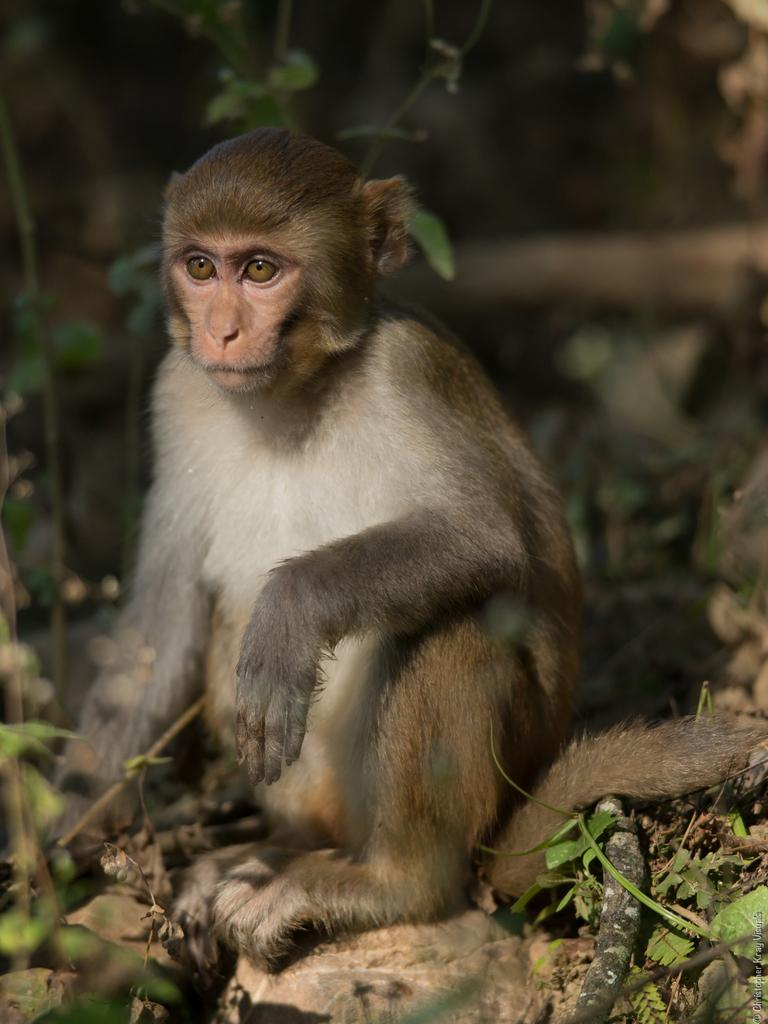What animal is present in the image? There is a monkey in the image. What is the monkey doing in the image? The monkey is sitting on the ground. In which direction is the monkey facing? The monkey is facing towards the left side. What can be seen at the bottom of the image? Few leaves are visible at the bottom of the image. How would you describe the background of the image? The background of the image is blurred. What type of cord is being used by the monkey in the image? There is no cord present in the image; the monkey is simply sitting on the ground. 